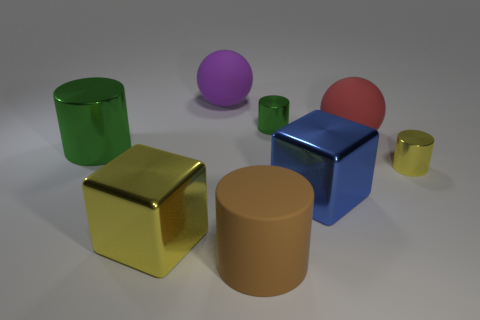Is the size of the green shiny thing that is on the left side of the large purple ball the same as the rubber object in front of the big blue metallic block?
Make the answer very short. Yes. What is the shape of the large purple thing that is the same material as the big red thing?
Your answer should be compact. Sphere. Are there any other things that are the same shape as the purple rubber thing?
Give a very brief answer. Yes. What is the color of the tiny cylinder that is in front of the big rubber ball that is in front of the tiny cylinder that is behind the large green cylinder?
Your answer should be very brief. Yellow. Are there fewer green things on the right side of the big red rubber ball than tiny yellow metal things that are to the left of the big rubber cylinder?
Offer a terse response. No. Does the big red object have the same shape as the purple matte object?
Make the answer very short. Yes. How many rubber spheres are the same size as the purple rubber thing?
Your answer should be compact. 1. Are there fewer green objects that are on the right side of the large red ball than brown rubber blocks?
Offer a very short reply. No. There is a yellow thing to the right of the large matte ball that is to the left of the tiny green metal cylinder; what size is it?
Your answer should be very brief. Small. What number of things are green cylinders or big red matte spheres?
Ensure brevity in your answer.  3. 